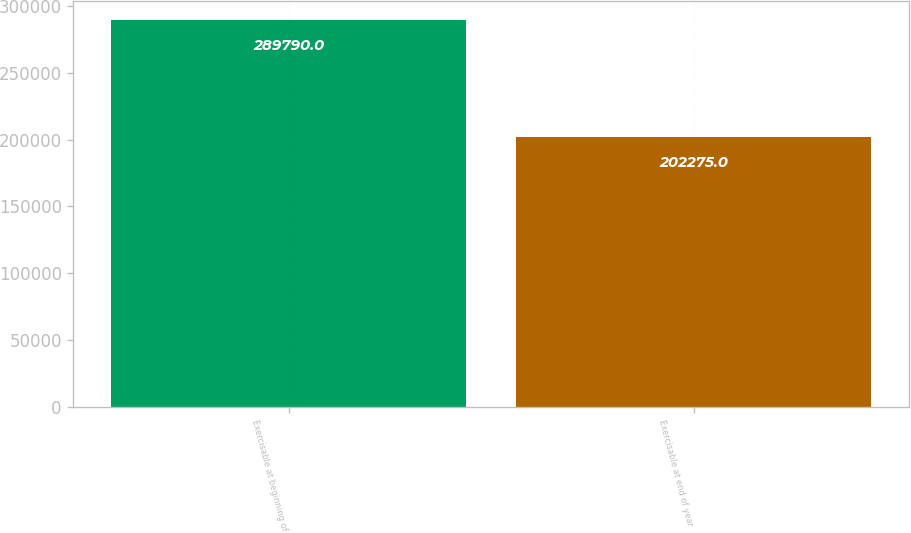<chart> <loc_0><loc_0><loc_500><loc_500><bar_chart><fcel>Exercisable at beginning of<fcel>Exercisable at end of year<nl><fcel>289790<fcel>202275<nl></chart> 